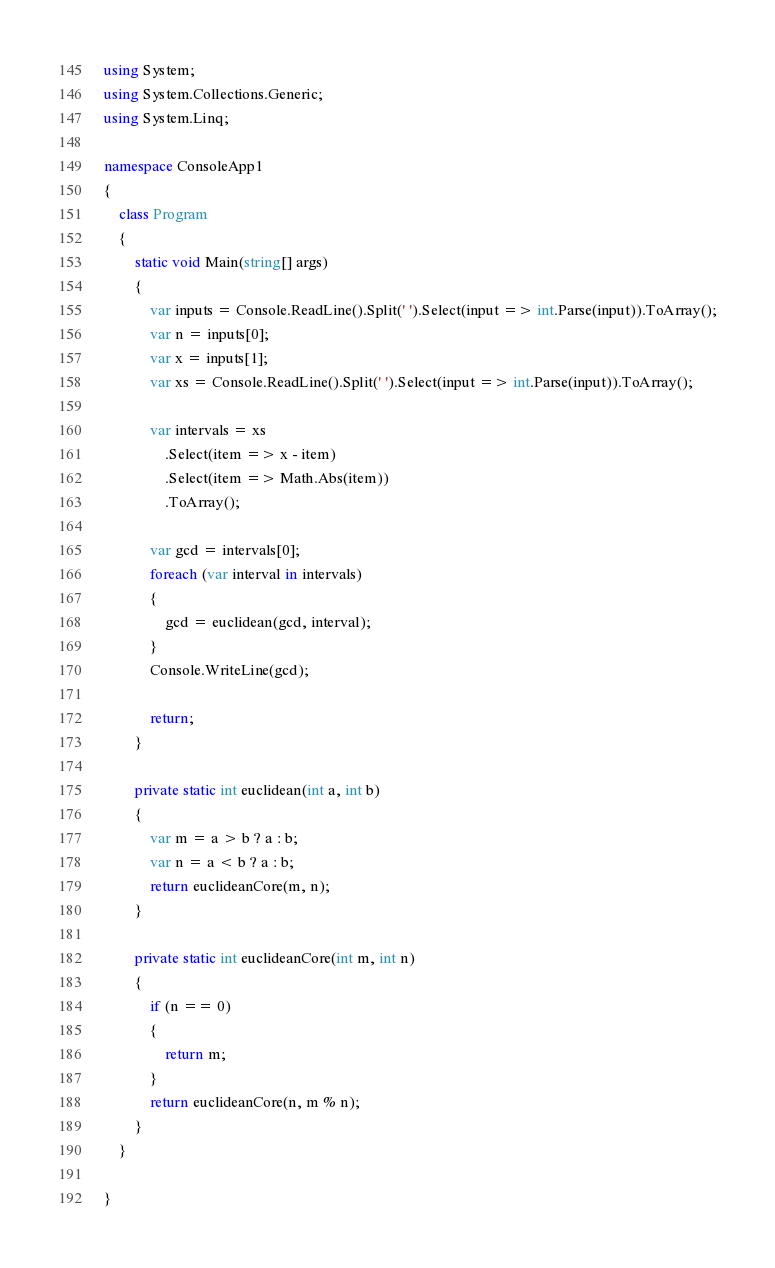<code> <loc_0><loc_0><loc_500><loc_500><_C#_>using System;
using System.Collections.Generic;
using System.Linq;

namespace ConsoleApp1
{
	class Program
	{
		static void Main(string[] args)
		{
			var inputs = Console.ReadLine().Split(' ').Select(input => int.Parse(input)).ToArray();
			var n = inputs[0];
			var x = inputs[1];
			var xs = Console.ReadLine().Split(' ').Select(input => int.Parse(input)).ToArray();

			var intervals = xs
				.Select(item => x - item)
				.Select(item => Math.Abs(item))
				.ToArray();

			var gcd = intervals[0];
			foreach (var interval in intervals)
			{
				gcd = euclidean(gcd, interval);
			}
			Console.WriteLine(gcd);

			return;
		}

		private static int euclidean(int a, int b)
		{
			var m = a > b ? a : b;
			var n = a < b ? a : b;
			return euclideanCore(m, n);
		}

		private static int euclideanCore(int m, int n)
		{
			if (n == 0)
			{
				return m;
			}
			return euclideanCore(n, m % n);
		}
	}

}
</code> 